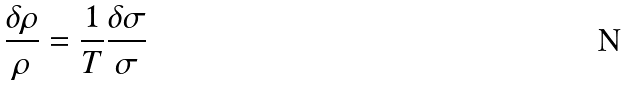<formula> <loc_0><loc_0><loc_500><loc_500>\frac { { \delta } { \rho } } { \rho } = \frac { 1 } { T } \frac { { \delta } { \sigma } } { \sigma }</formula> 